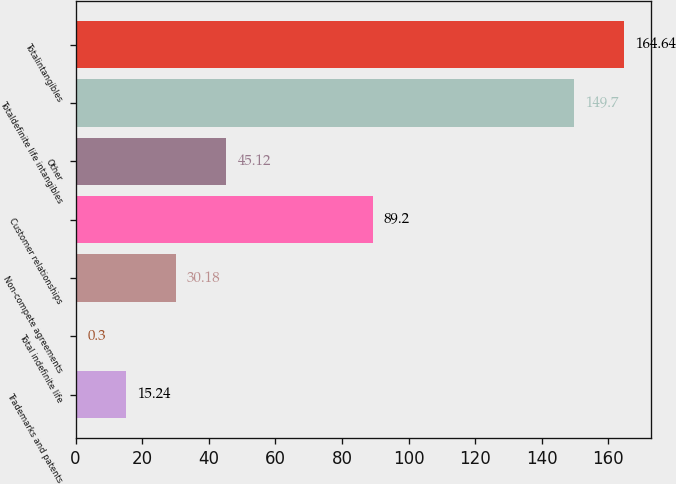<chart> <loc_0><loc_0><loc_500><loc_500><bar_chart><fcel>Trademarks and patents<fcel>Total indefinite life<fcel>Non-compete agreements<fcel>Customer relationships<fcel>Other<fcel>Totaldefinite life intangibles<fcel>Totalintangibles<nl><fcel>15.24<fcel>0.3<fcel>30.18<fcel>89.2<fcel>45.12<fcel>149.7<fcel>164.64<nl></chart> 